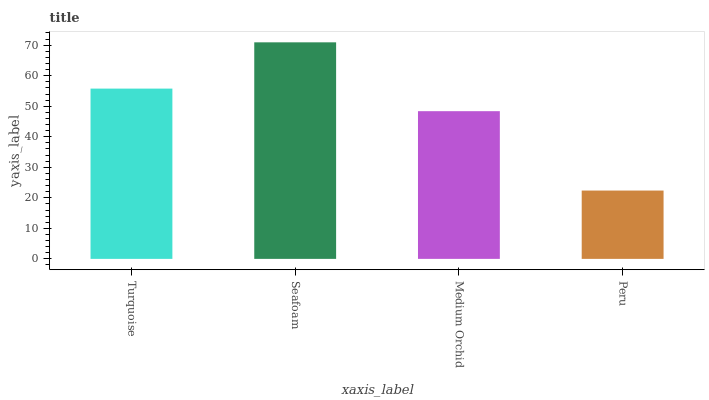Is Peru the minimum?
Answer yes or no. Yes. Is Seafoam the maximum?
Answer yes or no. Yes. Is Medium Orchid the minimum?
Answer yes or no. No. Is Medium Orchid the maximum?
Answer yes or no. No. Is Seafoam greater than Medium Orchid?
Answer yes or no. Yes. Is Medium Orchid less than Seafoam?
Answer yes or no. Yes. Is Medium Orchid greater than Seafoam?
Answer yes or no. No. Is Seafoam less than Medium Orchid?
Answer yes or no. No. Is Turquoise the high median?
Answer yes or no. Yes. Is Medium Orchid the low median?
Answer yes or no. Yes. Is Seafoam the high median?
Answer yes or no. No. Is Turquoise the low median?
Answer yes or no. No. 